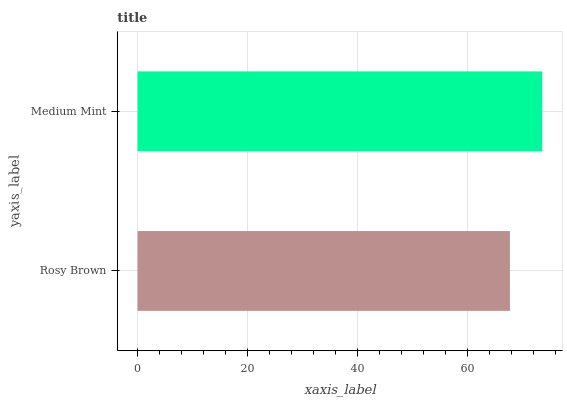Is Rosy Brown the minimum?
Answer yes or no. Yes. Is Medium Mint the maximum?
Answer yes or no. Yes. Is Medium Mint the minimum?
Answer yes or no. No. Is Medium Mint greater than Rosy Brown?
Answer yes or no. Yes. Is Rosy Brown less than Medium Mint?
Answer yes or no. Yes. Is Rosy Brown greater than Medium Mint?
Answer yes or no. No. Is Medium Mint less than Rosy Brown?
Answer yes or no. No. Is Medium Mint the high median?
Answer yes or no. Yes. Is Rosy Brown the low median?
Answer yes or no. Yes. Is Rosy Brown the high median?
Answer yes or no. No. Is Medium Mint the low median?
Answer yes or no. No. 